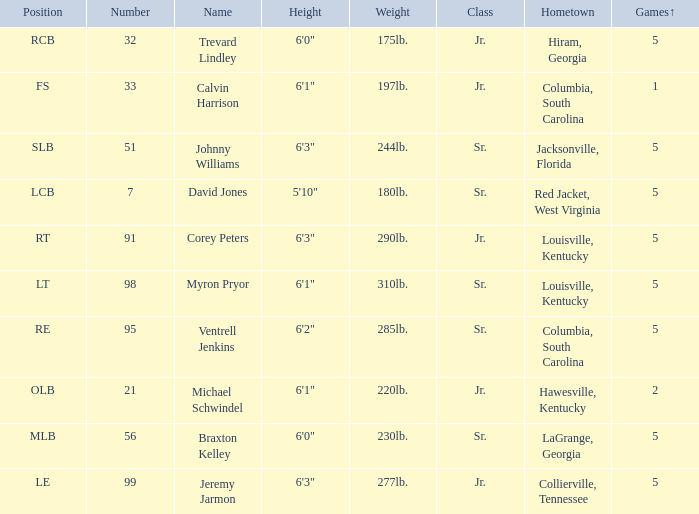How many players were 6'1" and from Columbia, South Carolina? 1.0. 